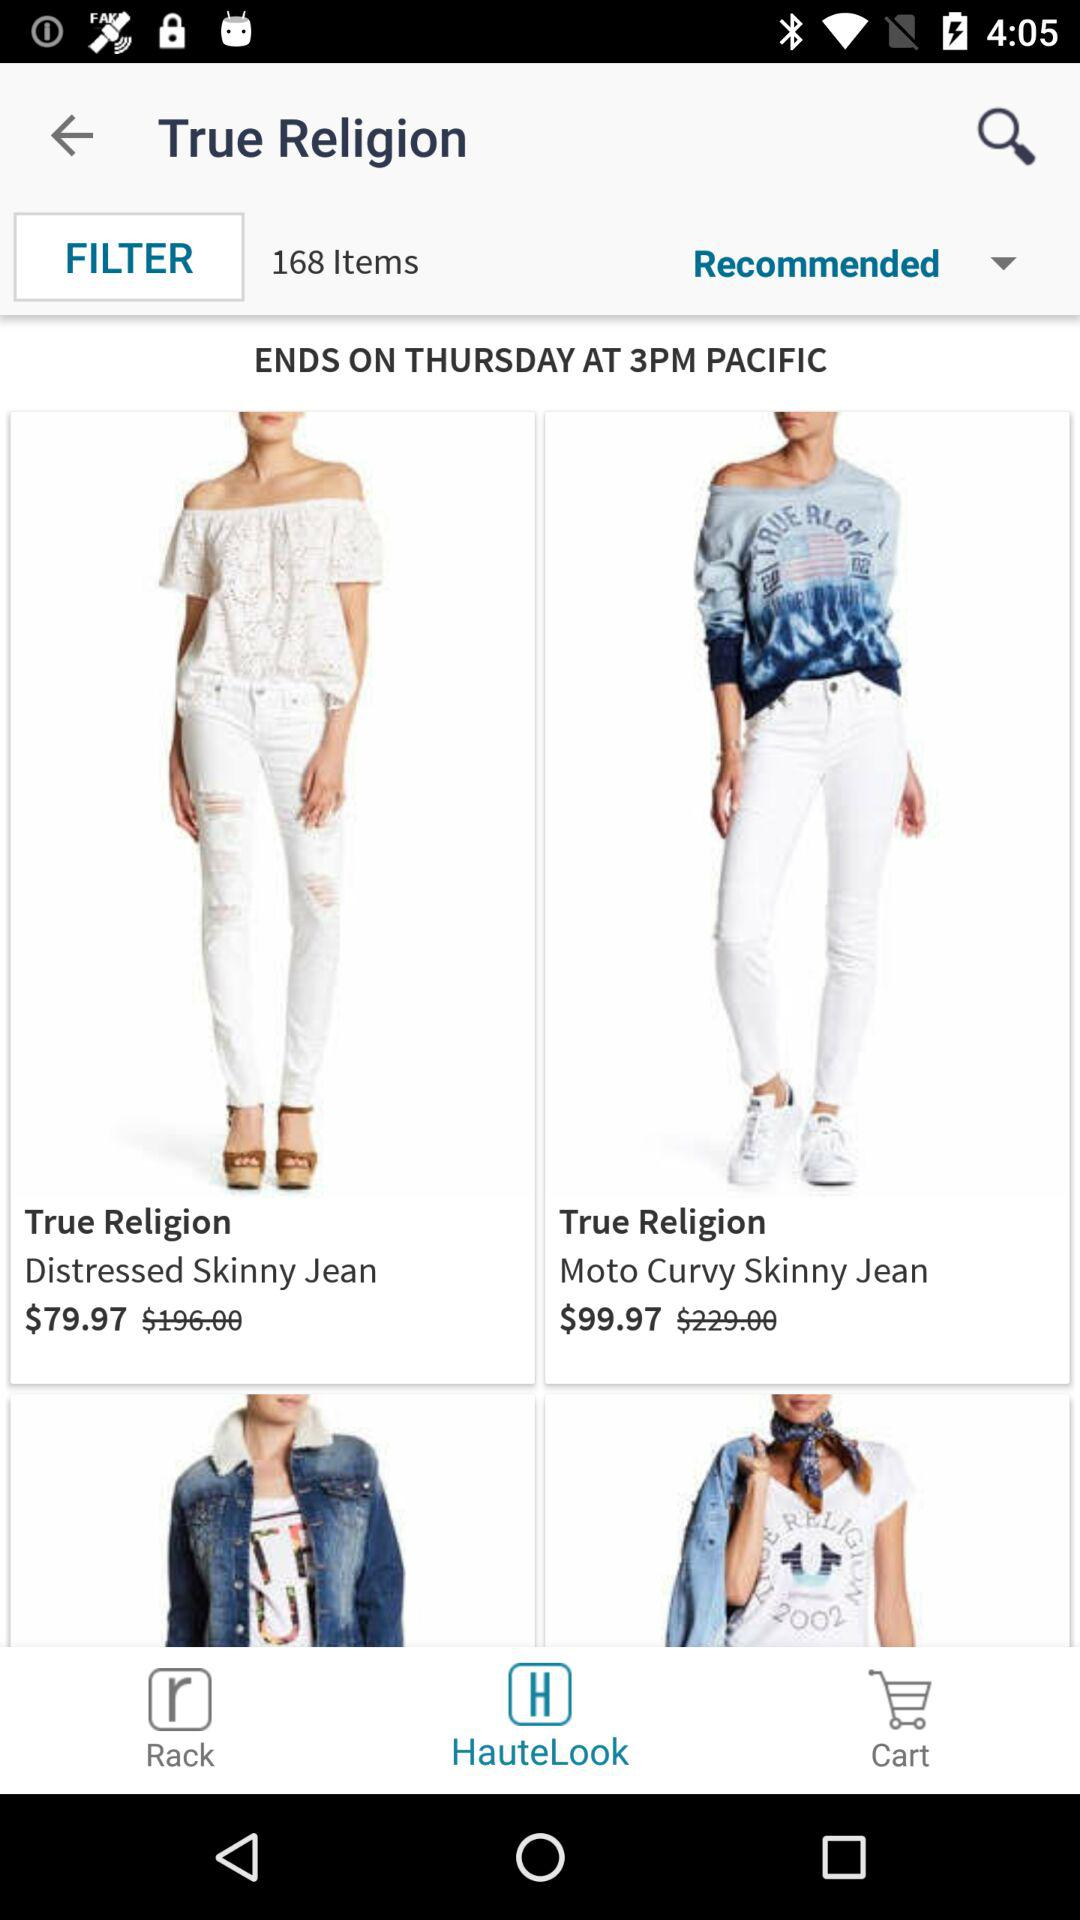At what time will the sale end? The sale will end on Thursday at 3 PM. 